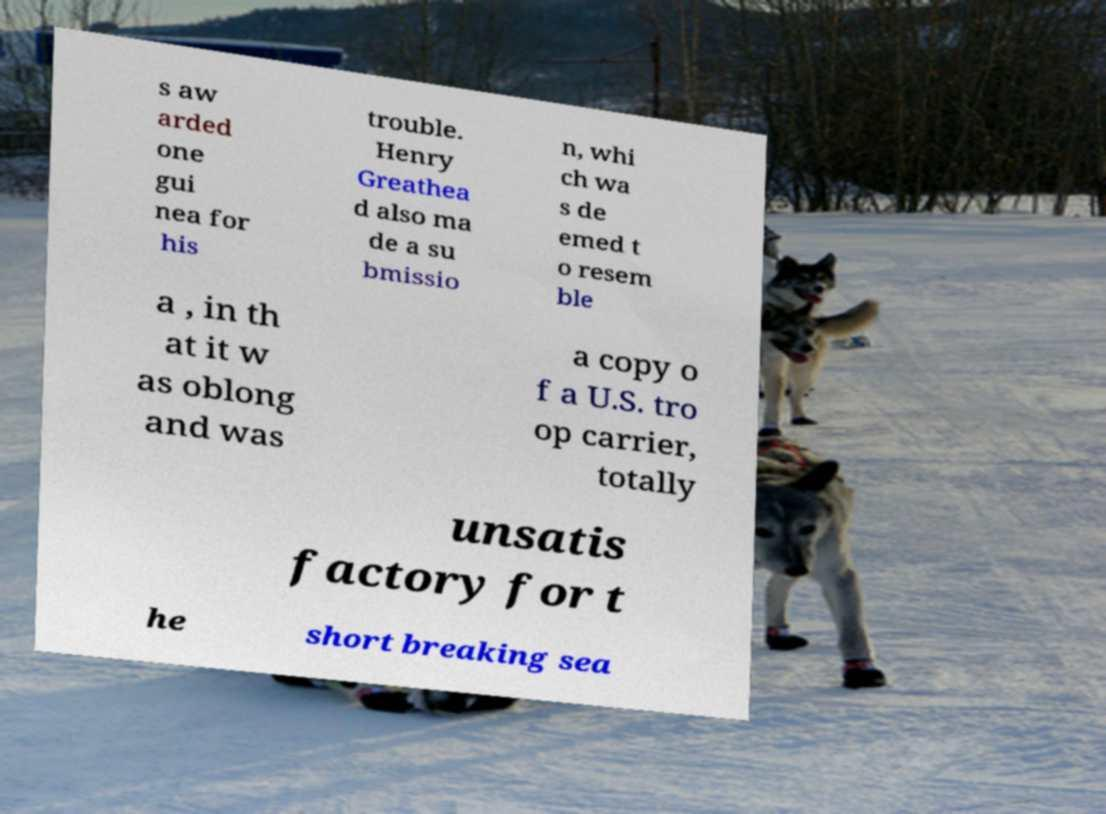Can you read and provide the text displayed in the image?This photo seems to have some interesting text. Can you extract and type it out for me? s aw arded one gui nea for his trouble. Henry Greathea d also ma de a su bmissio n, whi ch wa s de emed t o resem ble a , in th at it w as oblong and was a copy o f a U.S. tro op carrier, totally unsatis factory for t he short breaking sea 